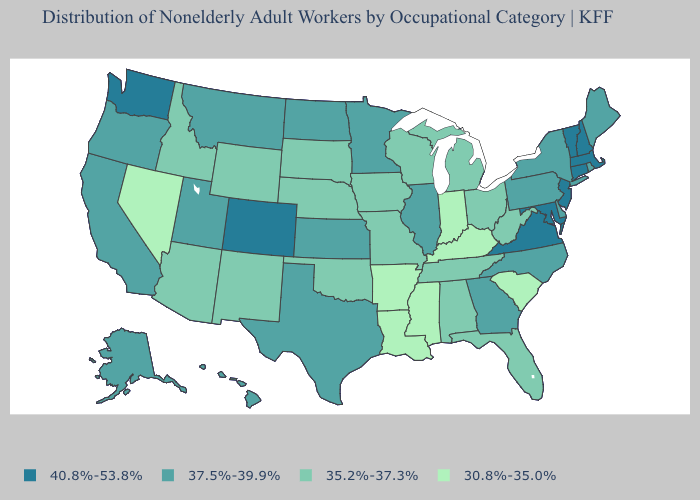How many symbols are there in the legend?
Short answer required. 4. Does New Mexico have the lowest value in the West?
Answer briefly. No. What is the value of Connecticut?
Short answer required. 40.8%-53.8%. Among the states that border West Virginia , which have the highest value?
Short answer required. Maryland, Virginia. Name the states that have a value in the range 30.8%-35.0%?
Write a very short answer. Arkansas, Indiana, Kentucky, Louisiana, Mississippi, Nevada, South Carolina. What is the lowest value in the USA?
Write a very short answer. 30.8%-35.0%. Which states have the lowest value in the USA?
Keep it brief. Arkansas, Indiana, Kentucky, Louisiana, Mississippi, Nevada, South Carolina. Among the states that border Maryland , which have the lowest value?
Quick response, please. West Virginia. What is the lowest value in states that border Alabama?
Be succinct. 30.8%-35.0%. What is the highest value in the USA?
Give a very brief answer. 40.8%-53.8%. How many symbols are there in the legend?
Be succinct. 4. Which states hav the highest value in the South?
Write a very short answer. Maryland, Virginia. Does Indiana have the lowest value in the MidWest?
Concise answer only. Yes. Name the states that have a value in the range 40.8%-53.8%?
Write a very short answer. Colorado, Connecticut, Maryland, Massachusetts, New Hampshire, New Jersey, Vermont, Virginia, Washington. Name the states that have a value in the range 35.2%-37.3%?
Quick response, please. Alabama, Arizona, Florida, Idaho, Iowa, Michigan, Missouri, Nebraska, New Mexico, Ohio, Oklahoma, South Dakota, Tennessee, West Virginia, Wisconsin, Wyoming. 